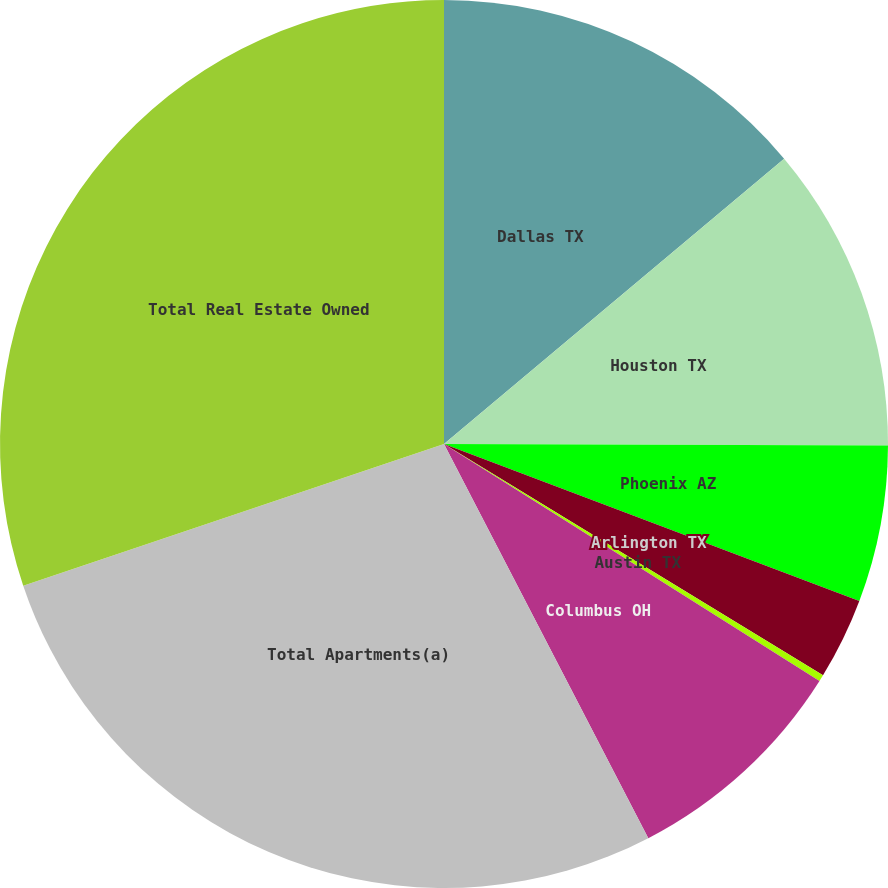Convert chart to OTSL. <chart><loc_0><loc_0><loc_500><loc_500><pie_chart><fcel>Dallas TX<fcel>Houston TX<fcel>Phoenix AZ<fcel>Arlington TX<fcel>Austin TX<fcel>Columbus OH<fcel>Total Apartments(a)<fcel>Total Real Estate Owned<nl><fcel>13.89%<fcel>11.16%<fcel>5.7%<fcel>2.97%<fcel>0.24%<fcel>8.43%<fcel>27.44%<fcel>30.17%<nl></chart> 